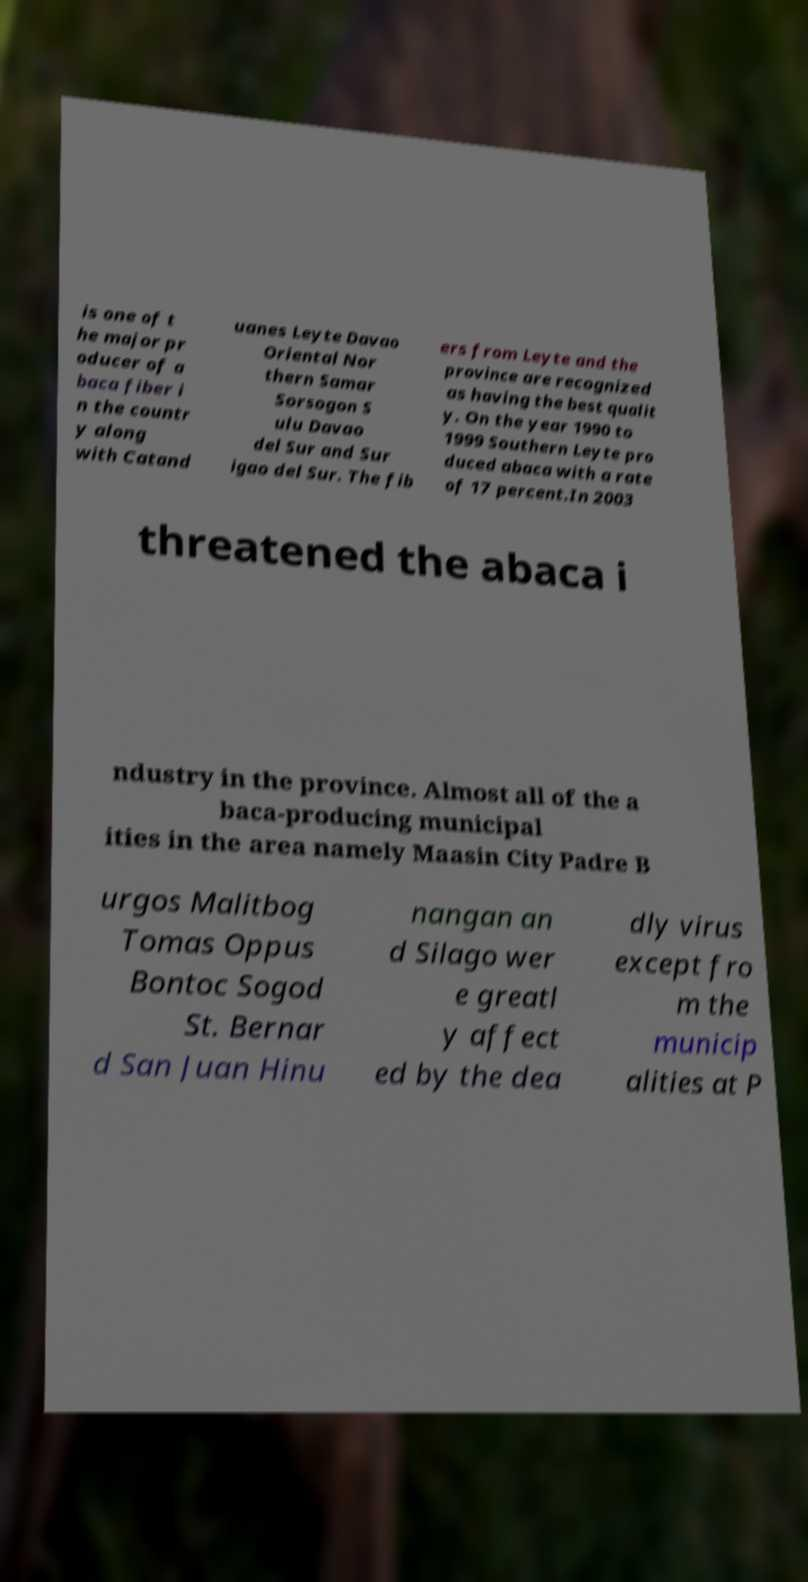Please identify and transcribe the text found in this image. is one of t he major pr oducer of a baca fiber i n the countr y along with Catand uanes Leyte Davao Oriental Nor thern Samar Sorsogon S ulu Davao del Sur and Sur igao del Sur. The fib ers from Leyte and the province are recognized as having the best qualit y. On the year 1990 to 1999 Southern Leyte pro duced abaca with a rate of 17 percent.In 2003 threatened the abaca i ndustry in the province. Almost all of the a baca-producing municipal ities in the area namely Maasin City Padre B urgos Malitbog Tomas Oppus Bontoc Sogod St. Bernar d San Juan Hinu nangan an d Silago wer e greatl y affect ed by the dea dly virus except fro m the municip alities at P 